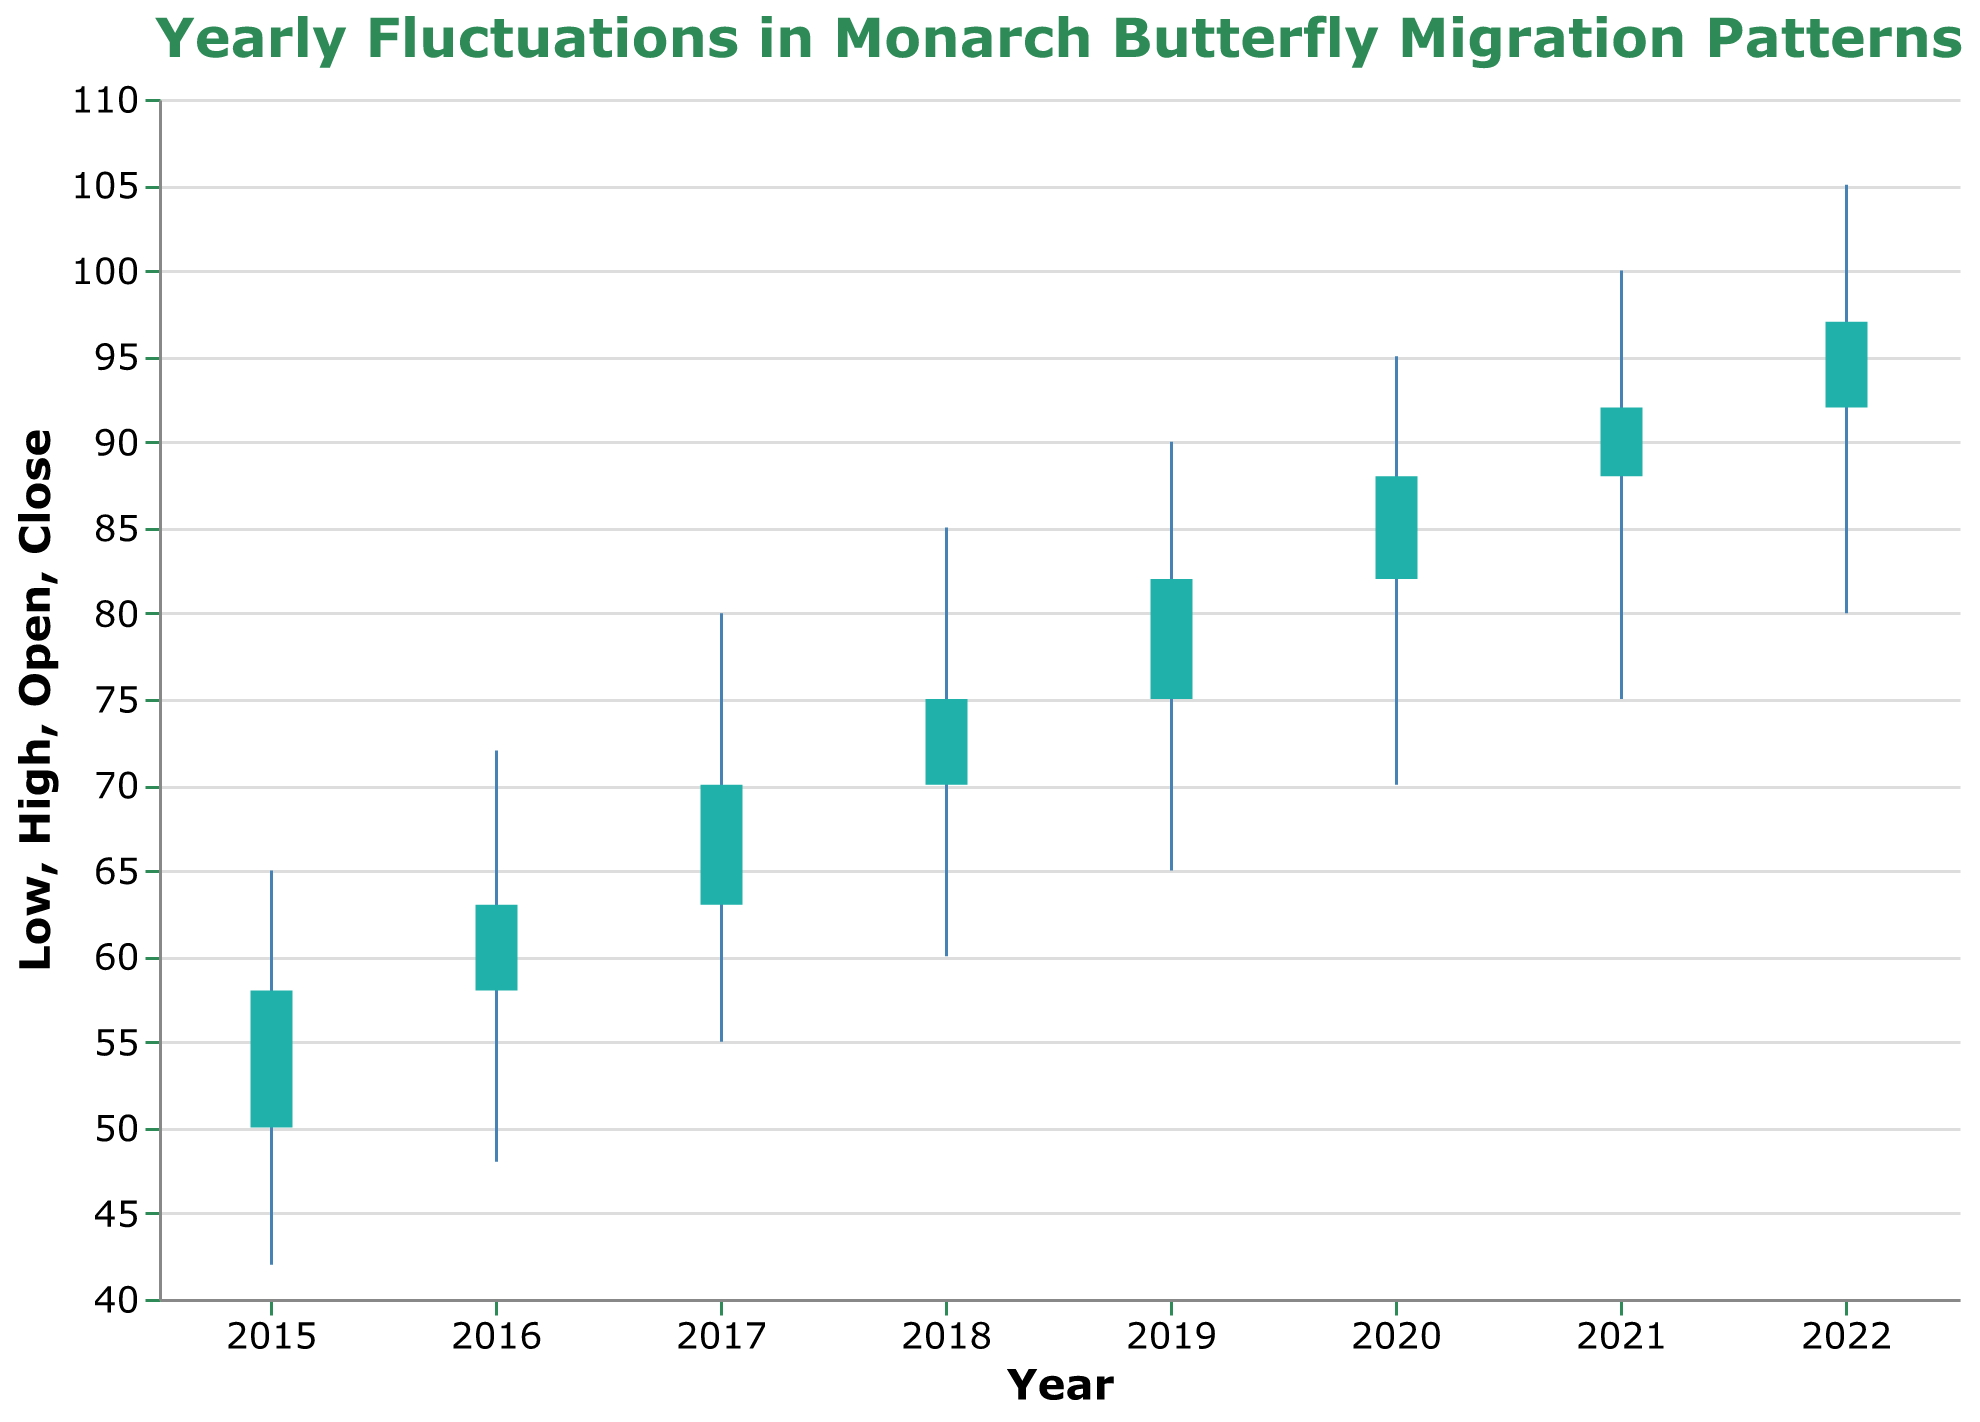What's the title of the figure? The title of the figure is displayed at the top and reads "Yearly Fluctuations in Monarch Butterfly Migration Patterns".
Answer: Yearly Fluctuations in Monarch Butterfly Migration Patterns What do the vertical lines represent in the OHLC chart? The vertical lines in the OHLC chart represent the range between the low and high migration pattern values for each year.
Answer: The range between the low and high values Which year had the highest close value? To find the highest close value, check the "Close" values for each year. The highest close is 97, which corresponds to the year 2022.
Answer: 2022 What are the markers below the open values used for? The markers below the open values (bars) signify the difference between the open (starting) and close (ending) values for the year.
Answer: The difference between the open and close values How did the high value change from 2015 to 2022? The high value started at 65 in 2015 and increased to 105 in 2022, showing an overall increase of 40 units over the years.
Answer: Increased by 40 What's the average low value over the given period? The low values are 42, 48, 55, 60, 65, 70, 75, and 80. Summing these gives 495. Dividing by the number of years (8) gives 495/8 = 61.88.
Answer: 61.88 How many years saw an increase in the close value compared to the previous year? Check each year's close value: from 2015 to 2016 (58 to 63), 2016 to 2017 (63 to 70), 2017 to 2018 (70 to 75), 2018 to 2019 (75 to 82), 2019 to 2020 (82 to 88), 2020 to 2021 (88 to 92), and 2021 to 2022 (92 to 97). All years saw an increase compared to the previous year, so there are 7 years with an increase.
Answer: 7 Which year experienced the largest fluctuation between the low and high values? The fluctuation can be calculated by subtracting the low from the high value for each year. The largest difference is (105 - 80) = 25, which occurred in 2022.
Answer: 2022 Was there any year where the close value was lower than the open value? Compare open and close values for each year. In all cases, the close value is higher or equal to the open value, so no year had a lower close than open.
Answer: No 